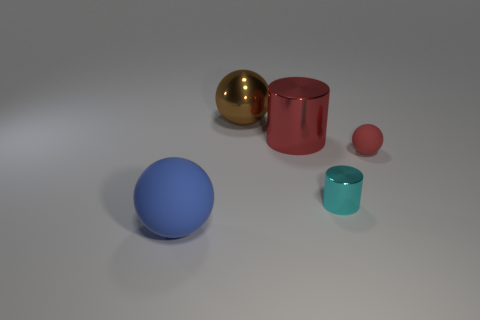How many things are small cyan metallic things that are in front of the red rubber object or large metal cylinders?
Give a very brief answer. 2. There is a blue thing that is made of the same material as the small ball; what size is it?
Ensure brevity in your answer.  Large. How many rubber objects are the same color as the metal ball?
Your answer should be very brief. 0. How many small objects are either cyan cylinders or brown matte cubes?
Offer a very short reply. 1. There is a thing that is the same color as the large cylinder; what is its size?
Offer a very short reply. Small. Is there a sphere made of the same material as the red cylinder?
Provide a short and direct response. Yes. There is a red thing that is on the right side of the large red metal object; what is it made of?
Your answer should be very brief. Rubber. Is the color of the big sphere that is on the right side of the large blue matte sphere the same as the cylinder that is on the left side of the tiny cylinder?
Provide a short and direct response. No. There is a matte thing that is the same size as the red metallic object; what color is it?
Provide a short and direct response. Blue. What number of other things are there of the same shape as the blue matte thing?
Your answer should be very brief. 2. 